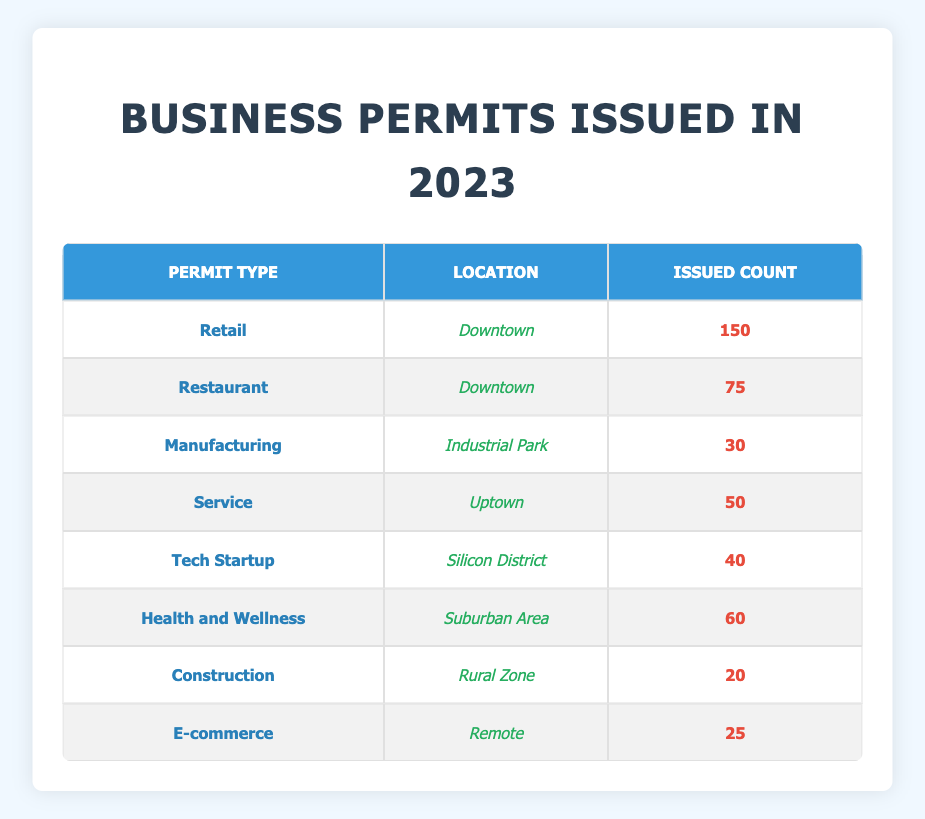What is the total count of business permits issued for the Retail sector? Looking at the table, there is one row for the Retail sector located in Downtown, which shows an issued count of 150 permits. Therefore, this is the total count since it's the only entry for this sector.
Answer: 150 How many business permits were issued in the Downtown area? The Downtown area has two entries in the table: Retail with 150 permits and Restaurant with 75 permits. Adding these counts together gives a total of 150 + 75 = 225 permits.
Answer: 225 Is there a Health and Wellness permit issued in the Rural Zone? Looking at the table, the Health and Wellness permit is issued in the Suburban Area, while the Rural Zone has permits only for Construction. Thus, the answer is no.
Answer: No What permit type has the highest number of issued permits? By reviewing the issued counts listed in the table, the Retail sector has the highest count with 150 permits, surpassing all other types listed.
Answer: Retail What is the average count of permits issued across all types? Summing up all issued counts: 150 + 75 + 30 + 50 + 40 + 60 + 20 + 25 = 450 permits. Since there are 8 permit types, the average is 450/8 = 56.25.
Answer: 56.25 How many more permits were issued in Downtown compared to the Uptown area? The total issued permits in Downtown are 150 (Retail) + 75 (Restaurant) = 225. The Uptown area has 50 (Service). Therefore, the difference is 225 - 50 = 175.
Answer: 175 Are there more permits issued for Tech Startups than for Construction permits? The table shows 40 permits for Tech Startups and 20 for Construction. Therefore, it’s true that there are more for Tech Startups.
Answer: Yes What locations are represented in the table with issued permits? By examining the locations in the table, the unique locations are: Downtown, Industrial Park, Uptown, Silicon District, Suburban Area, Rural Zone, and Remote. Therefore, a total of 7 different locations are represented.
Answer: 7 